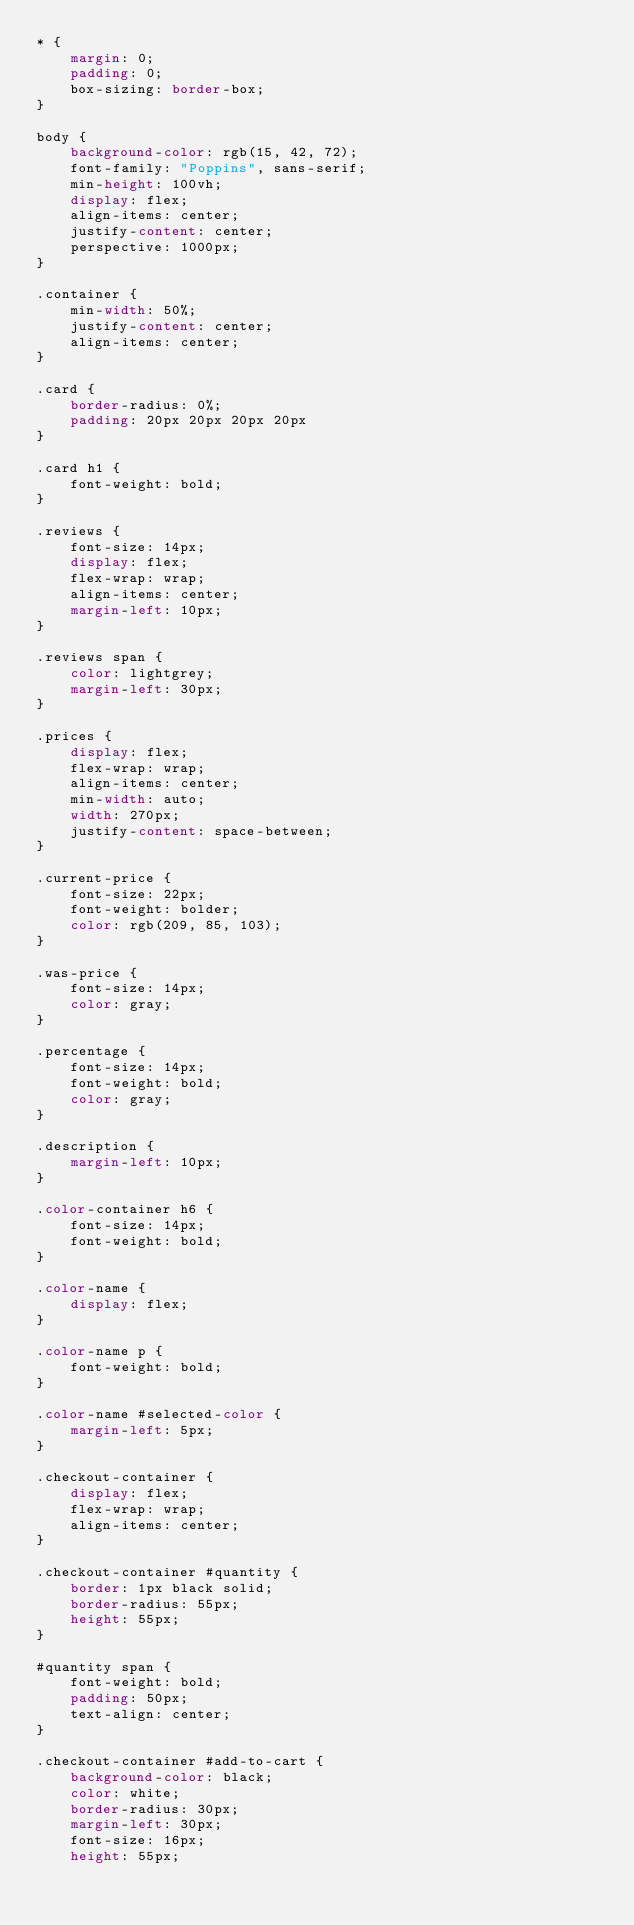<code> <loc_0><loc_0><loc_500><loc_500><_CSS_>* {
    margin: 0;
    padding: 0;
    box-sizing: border-box;
}

body {
    background-color: rgb(15, 42, 72);
    font-family: "Poppins", sans-serif;
    min-height: 100vh;
    display: flex;
    align-items: center;
    justify-content: center;
    perspective: 1000px;
}

.container {
    min-width: 50%;
    justify-content: center;
    align-items: center;
}

.card {
    border-radius: 0%;
    padding: 20px 20px 20px 20px
}

.card h1 {
    font-weight: bold;
}

.reviews {
    font-size: 14px;
    display: flex;
    flex-wrap: wrap;
    align-items: center;
    margin-left: 10px;
}

.reviews span {
    color: lightgrey;
    margin-left: 30px;
}

.prices {
    display: flex;
    flex-wrap: wrap;
    align-items: center;
    min-width: auto;
    width: 270px;
    justify-content: space-between;
}

.current-price {
    font-size: 22px;
    font-weight: bolder;
    color: rgb(209, 85, 103);
}

.was-price {
    font-size: 14px;
    color: gray;
}

.percentage {
    font-size: 14px;
    font-weight: bold;
    color: gray;
}

.description {
    margin-left: 10px;
}

.color-container h6 {
    font-size: 14px;
    font-weight: bold;
}

.color-name {
    display: flex;
}

.color-name p {
    font-weight: bold;
}

.color-name #selected-color {
    margin-left: 5px;
}

.checkout-container {
    display: flex;
    flex-wrap: wrap;
    align-items: center;
}

.checkout-container #quantity {
    border: 1px black solid;
    border-radius: 55px;
    height: 55px;
}

#quantity span {
    font-weight: bold;
    padding: 50px;
    text-align: center;
}

.checkout-container #add-to-cart {
    background-color: black;
    color: white;
    border-radius: 30px;
    margin-left: 30px;
    font-size: 16px;
    height: 55px;</code> 